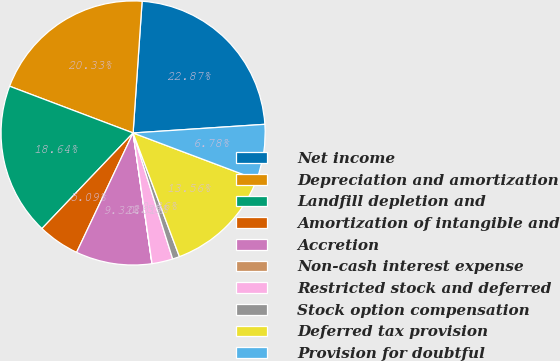<chart> <loc_0><loc_0><loc_500><loc_500><pie_chart><fcel>Net income<fcel>Depreciation and amortization<fcel>Landfill depletion and<fcel>Amortization of intangible and<fcel>Accretion<fcel>Non-cash interest expense<fcel>Restricted stock and deferred<fcel>Stock option compensation<fcel>Deferred tax provision<fcel>Provision for doubtful<nl><fcel>22.87%<fcel>20.33%<fcel>18.64%<fcel>5.09%<fcel>9.32%<fcel>0.01%<fcel>2.55%<fcel>0.86%<fcel>13.56%<fcel>6.78%<nl></chart> 